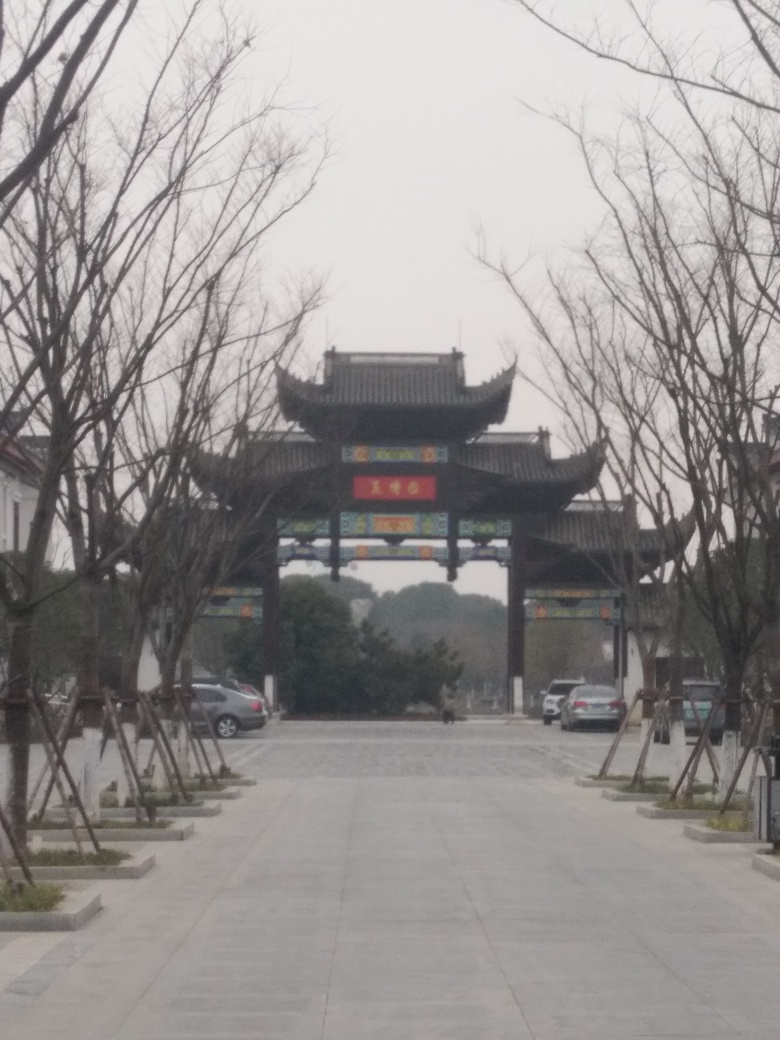Could you inform me if this image is taken during a specific event or a day-to-day scene? The image appears to capture a day-to-day scene rather than a specific event. The absence of decorations that might indicate a festival or event, coupled with the casual stance of the person walking and the parked cars to the side suggest this is a common snapshot of everyday life at this location. 